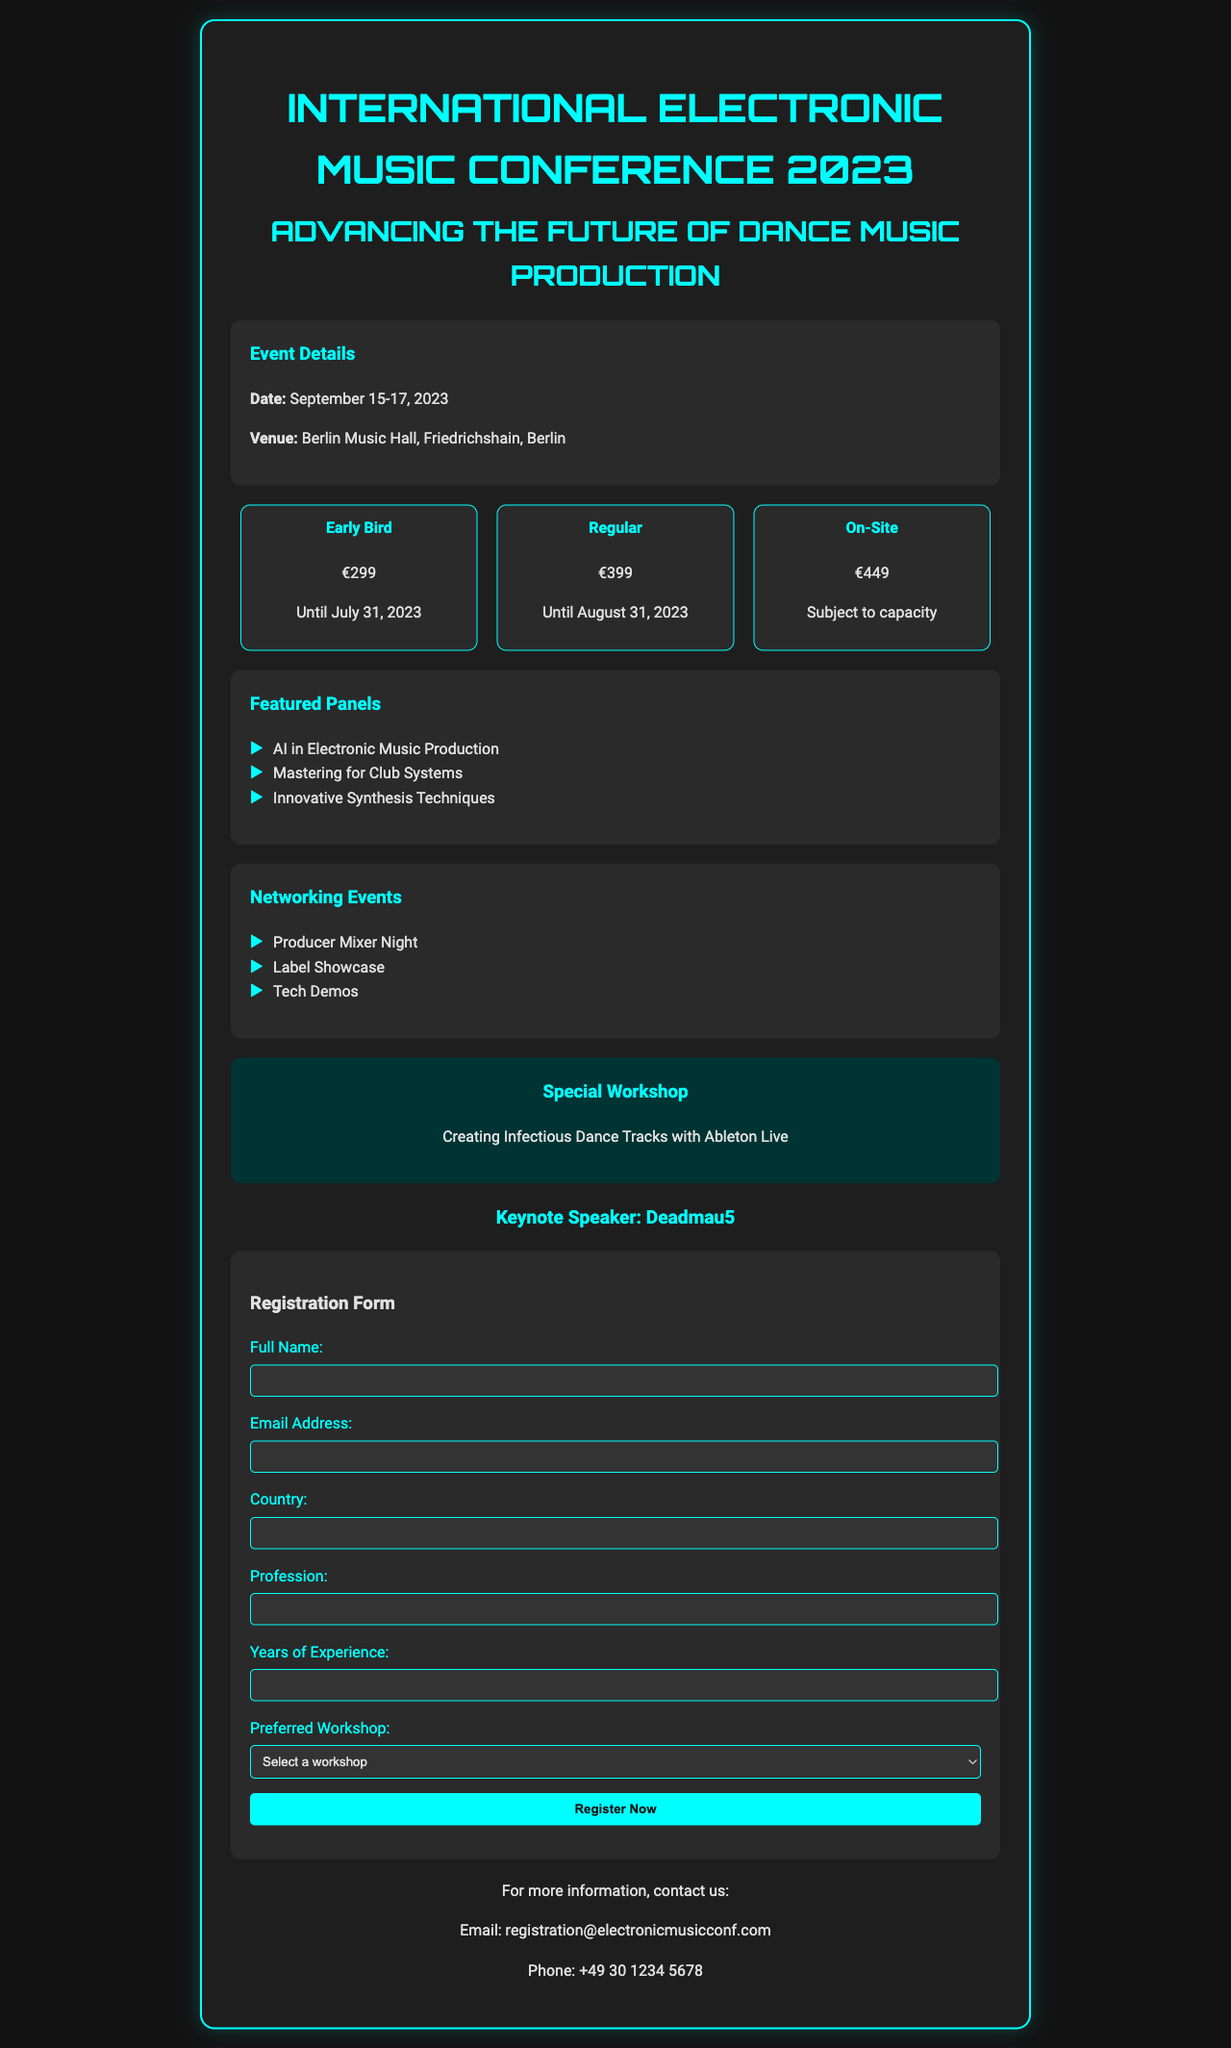What is the date of the conference? The conference is scheduled to take place from September 15 to 17, 2023.
Answer: September 15-17, 2023 Where is the venue located? The registration form indicates the venue is Berlin Music Hall, Friedrichshain, Berlin.
Answer: Berlin Music Hall, Friedrichshain, Berlin What is the price for early bird registration? The document states that the price for early bird registration is €299 until July 31, 2023.
Answer: €299 Who is the keynote speaker? The document highlights that Deadmau5 will be the keynote speaker at the conference.
Answer: Deadmau5 How many years of experience is required for registration? The registration form specifies a field for years of experience that is required to fill out.
Answer: Required (not specified number) What is one of the special workshops offered? The document lists "Creating Infectious Dance Tracks with Ableton Live" as a special workshop.
Answer: Creating Infectious Dance Tracks with Ableton Live What is included in the networking events? The document mentions several networking events such as Producer Mixer Night, Label Showcase, and Tech Demos.
Answer: Producer Mixer Night, Label Showcase, Tech Demos What type of information can you contact for? The contact section provides an email and phone number for more information regarding the registration.
Answer: Registration information 